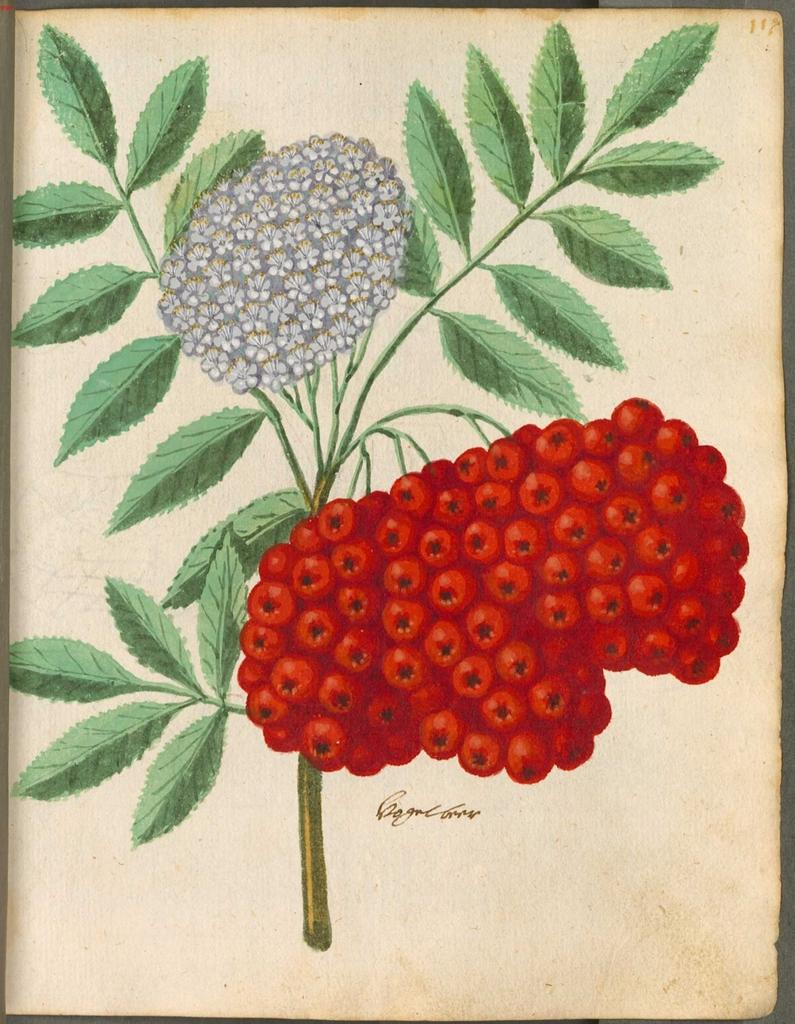What is depicted on the paper in the image? The art on the paper includes green leaves, white colored flowers, and red color fruits. What other element is present on the paper besides the art? There is text on the paper. What musical instrument is being played in the image? There is no musical instrument or any indication of music being played in the image; it primarily features a paper with art and text. 